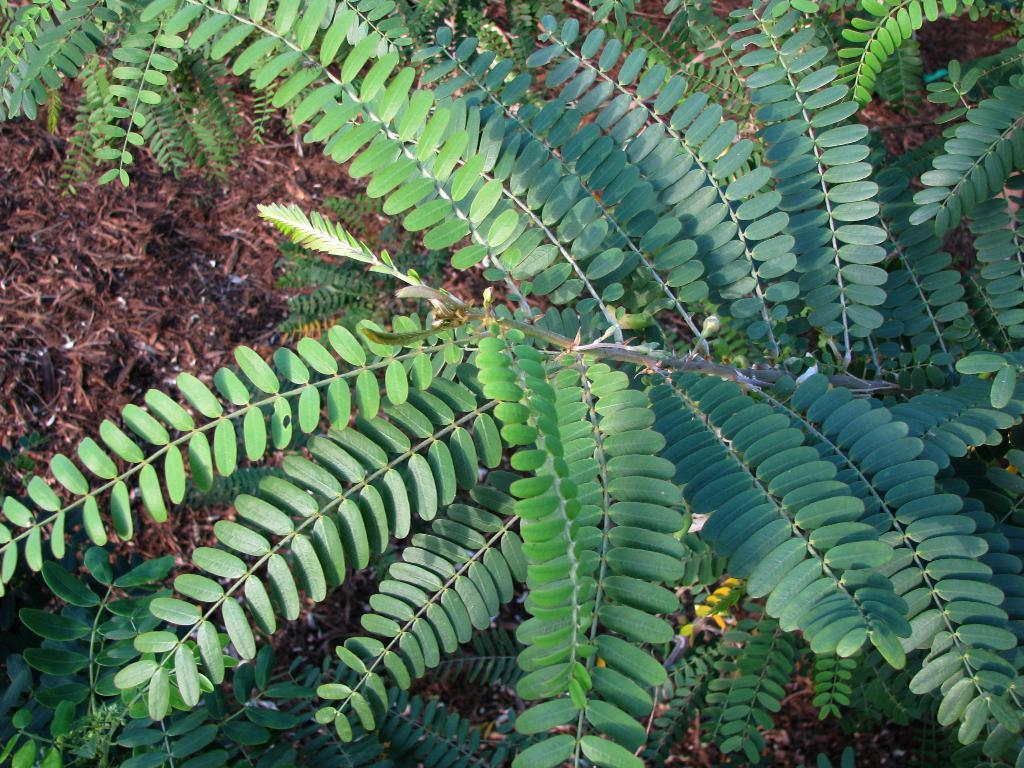What type of plant can be seen in the image? There is a tree in the image. What can be found on the left side of the image? There are twigs of the soil on the left side of the image. What is the color of the twigs? The twigs are brown in color. What type of fear is depicted in the image? There is no fear depicted in the image; it only features a tree and twigs. What is the bucket used for in the image? There is no bucket present in the image. What type of face can be seen on the tree in the image? There is no face present on the tree in the image. 